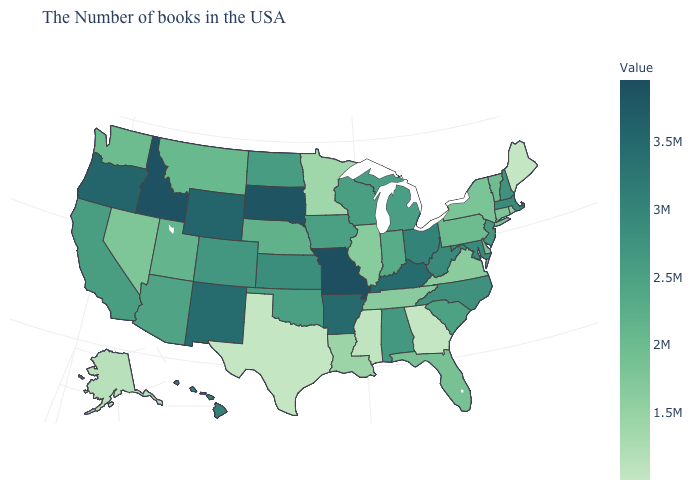Among the states that border Oregon , which have the highest value?
Concise answer only. Idaho. 